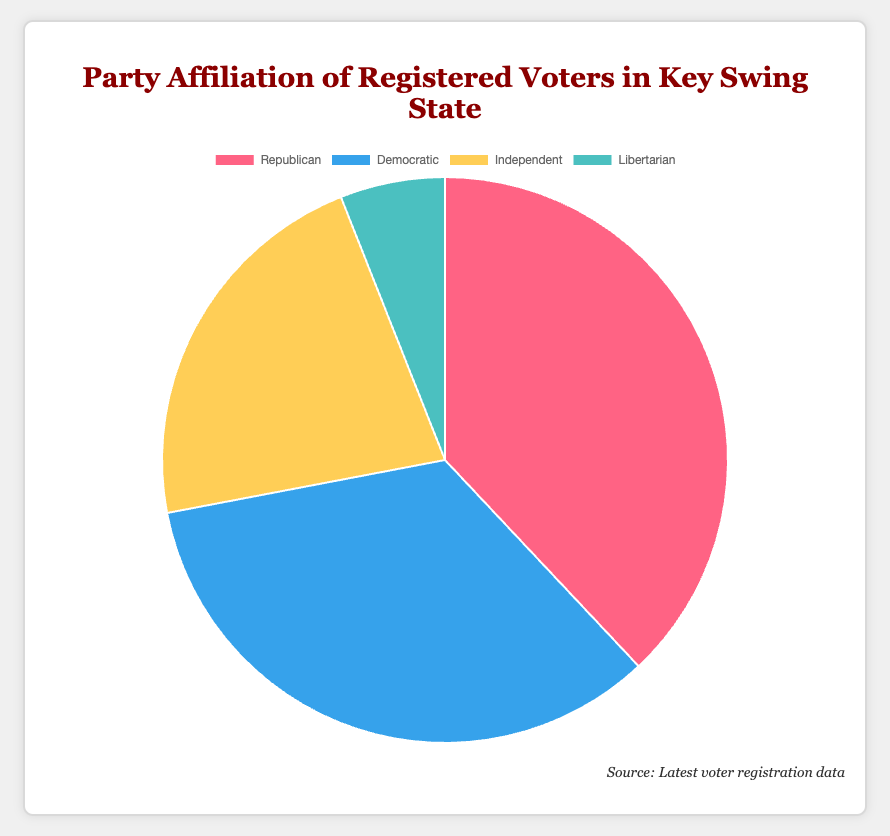What percentage of registered voters identify as Republicans? The figure shows a pie chart with segments labeled by party affiliation. The segment labeled "Republican" shows 38%.
Answer: 38% What is the total percentage of registered voters that identify as Independents or Libertarians? The pie chart shows Independent voters at 22% and Libertarian voters at 6%. Adding these percentages gives 22% + 6% = 28%.
Answer: 28% Which party has a smaller percentage of registered voters: Democratic or Independent? According to the pie chart, Democrats have 34% of registered voters, and Independents have 22%. Since 34% is greater than 22%, the Independent party has a smaller percentage.
Answer: Independent What is the difference in percentage between Republican and Democratic voters? The pie chart indicates that Republicans have 38% and Democrats have 34%. The difference is 38% - 34% = 4%.
Answer: 4% Which party segment on the pie chart is represented by the color blue? The pie chart uses colors to represent different parties. The segment labeled "Democratic" is shown in blue.
Answer: Democratic If the percentages of Republican and Democratic voters were combined, what would be the total percentage? The pie chart shows Republicans at 38% and Democrats at 34%. Adding these percentages gives 38% + 34% = 72%.
Answer: 72% Out of the four parties shown, which one has the least percentage of registered voters? The pie chart shows four parties: Republican (38%), Democratic (34%), Independent (22%), and Libertarian (6%). Libertarian has the smallest percentage.
Answer: Libertarian What percentage of registered voters are not affiliated with either the Republican or Democratic parties? According to the pie chart, Independents are 22% and Libertarians are 6%. Adding these gives 22% + 6% = 28%.
Answer: 28% Is the sum of the percentages of Republican and Independent voters greater than 50%? The pie chart shows Republicans at 38% and Independents at 22%. Summing these gives 38% + 22% = 60%, which is greater than 50%.
Answer: Yes 